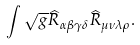Convert formula to latex. <formula><loc_0><loc_0><loc_500><loc_500>\int \sqrt { g } \widehat { R } _ { \alpha \beta \gamma \delta } \widehat { R } _ { \mu \nu \lambda \rho } .</formula> 